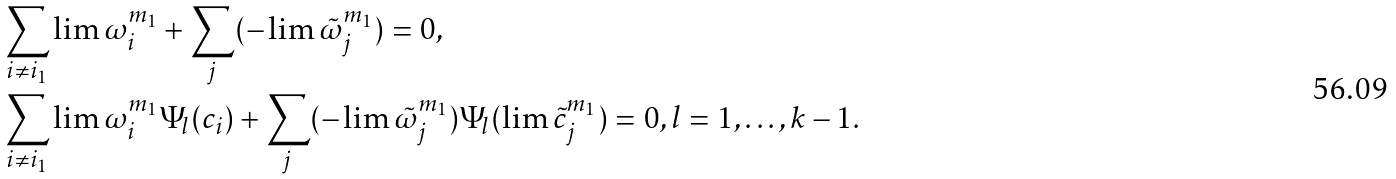<formula> <loc_0><loc_0><loc_500><loc_500>& \sum _ { i \ne i _ { 1 } } \lim \omega _ { i } ^ { m _ { 1 } } + \sum _ { j } ( - \lim \tilde { \omega } _ { j } ^ { m _ { 1 } } ) = 0 , \\ & \sum _ { i \ne i _ { 1 } } \lim \omega _ { i } ^ { m _ { 1 } } \Psi _ { l } ( c _ { i } ) + \sum _ { j } ( - \lim \tilde { \omega } _ { j } ^ { m _ { 1 } } ) \Psi _ { l } ( \lim \tilde { c } _ { j } ^ { m _ { 1 } } ) = 0 , l = 1 , \dots , k - 1 .</formula> 